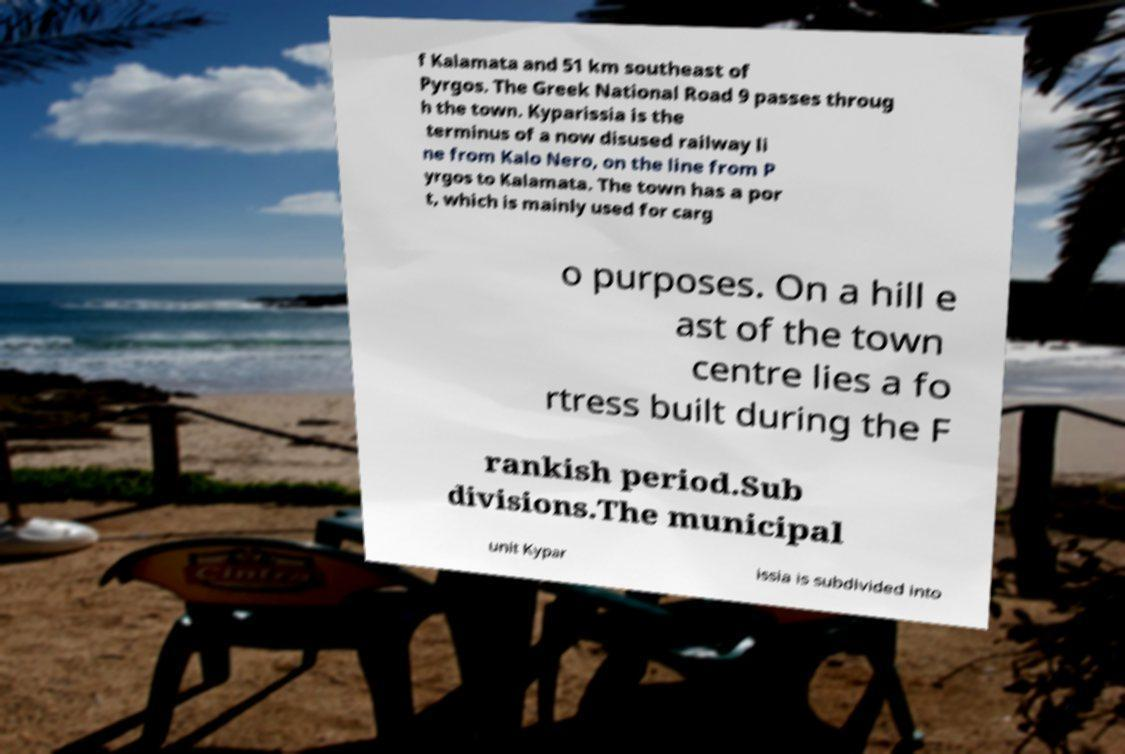Can you read and provide the text displayed in the image?This photo seems to have some interesting text. Can you extract and type it out for me? f Kalamata and 51 km southeast of Pyrgos. The Greek National Road 9 passes throug h the town. Kyparissia is the terminus of a now disused railway li ne from Kalo Nero, on the line from P yrgos to Kalamata. The town has a por t, which is mainly used for carg o purposes. On a hill e ast of the town centre lies a fo rtress built during the F rankish period.Sub divisions.The municipal unit Kypar issia is subdivided into 